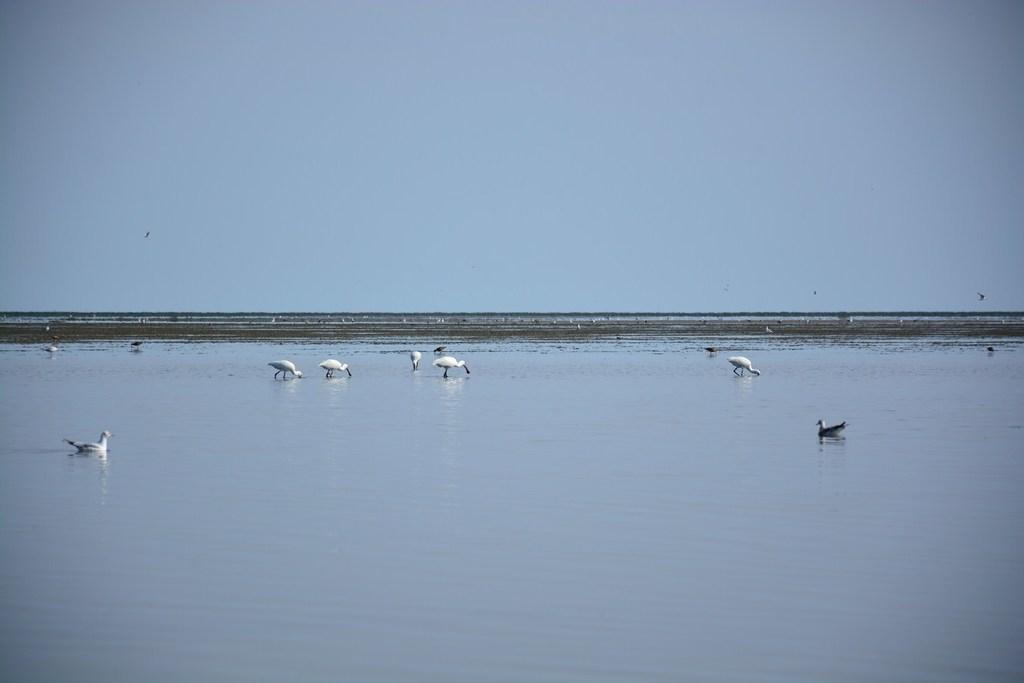What type of animals can be seen in the image? There are birds on the surface of the water in the image. What type of terrain is visible in the image? Soil is visible in the image. What part of the natural environment is visible in the image? The sky is visible in the image. What type of waste can be seen in the image? There is no waste present in the image. What type of tank is visible in the image? There is no tank present in the image. 